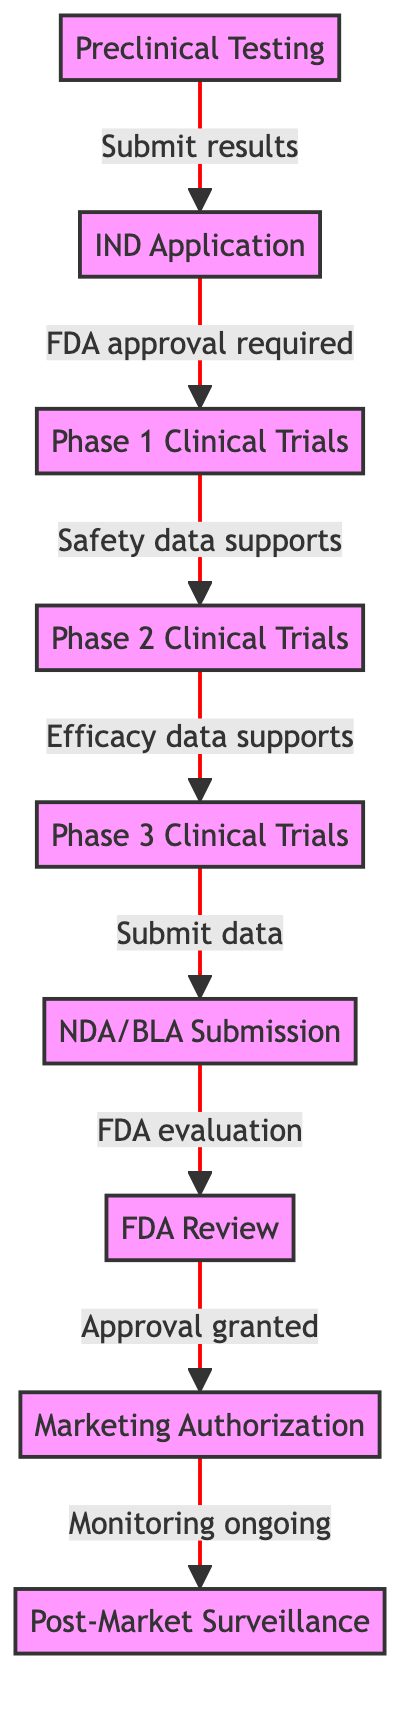What is the first step in the regulatory approval process? The diagram starts with "Preclinical Testing", which indicates it is the initial stage of the regulatory approval process.
Answer: Preclinical Testing How many phases of clinical trials are there? The diagram contains three distinct phases labeled as "Phase 1 Clinical Trials", "Phase 2 Clinical Trials", and "Phase 3 Clinical Trials", indicating there are a total of three phases.
Answer: 3 What document must be submitted after completing the clinical trial phases? According to the diagram, after completing the clinical trials, the next step is to submit the "NDA/BLA Submission". This document is crucial for regulatory approval.
Answer: NDA/BLA Submission What is required before moving from the IND Application to Phase 1 Clinical Trials? The diagram indicates that "FDA approval required" is a prerequisite to advance from the "IND Application" node to the "Phase 1 Clinical Trials" node.
Answer: FDA approval required Which phase supports safety data? The relationship shown in the diagram indicates that "Phase 1 Clinical Trials" supports safety data, as it leads to the next node "Phase 2 Clinical Trials".
Answer: Phase 1 Clinical Trials What follows after receiving FDA review? The diagram specifies that after "FDA Review", the next step is "Approval granted", which leads to "Marketing Authorization".
Answer: Approval granted What stage involves monitoring ongoing after marketing authorization? The diagram illustrates that "Post-Market Surveillance" is the stage that takes place following "Marketing Authorization", indicating a focus on ongoing monitoring.
Answer: Post-Market Surveillance How many total nodes are represented in the diagram? The diagram clearly shows a total of nine nodes, each representing a distinct step in the regulatory approval process from "Preclinical Testing" to "Marketing Authorization."
Answer: 9 What is necessary to transition between Phase 2 and Phase 3 Clinical Trials? The diagram states that the transition from Phase 2 to Phase 3 occurs because "Efficacy data supports", indicating a requirement for strong efficacy data.
Answer: Efficacy data supports What happens after submitting the NDA/BLA? Following the submission of the "NDA/BLA", the diagram indicates that the next action is an "FDA evaluation", which is critical for moving forward with the approval process.
Answer: FDA evaluation 